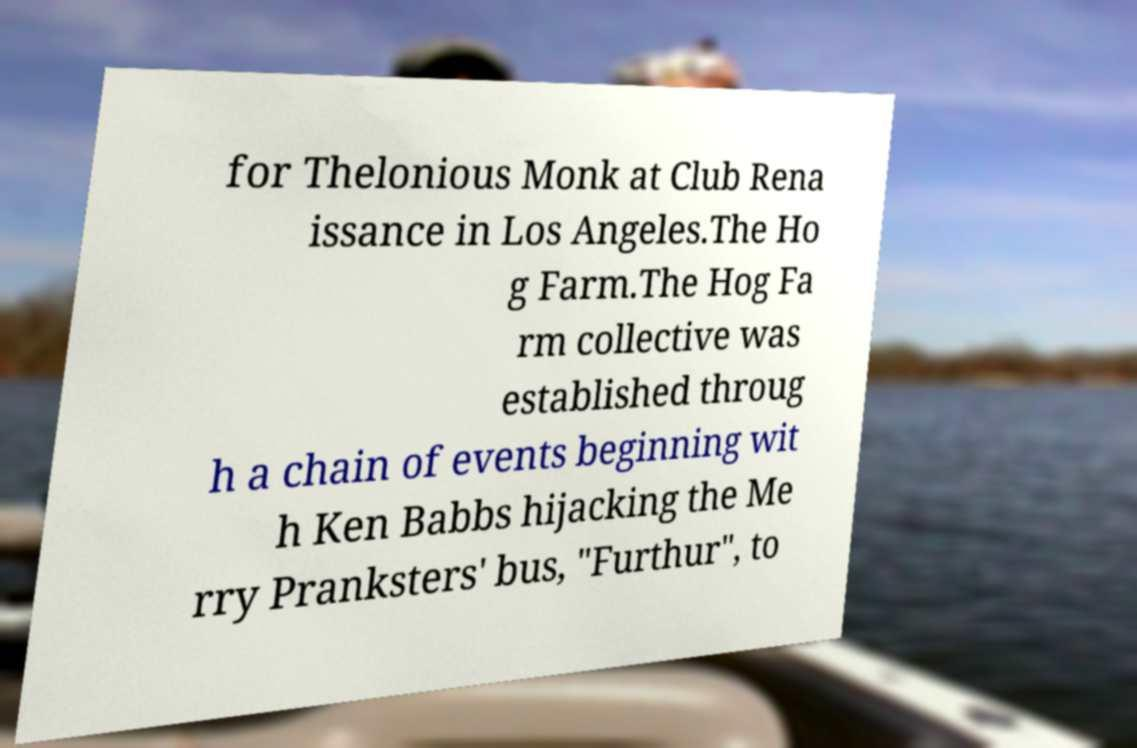Could you extract and type out the text from this image? for Thelonious Monk at Club Rena issance in Los Angeles.The Ho g Farm.The Hog Fa rm collective was established throug h a chain of events beginning wit h Ken Babbs hijacking the Me rry Pranksters' bus, "Furthur", to 